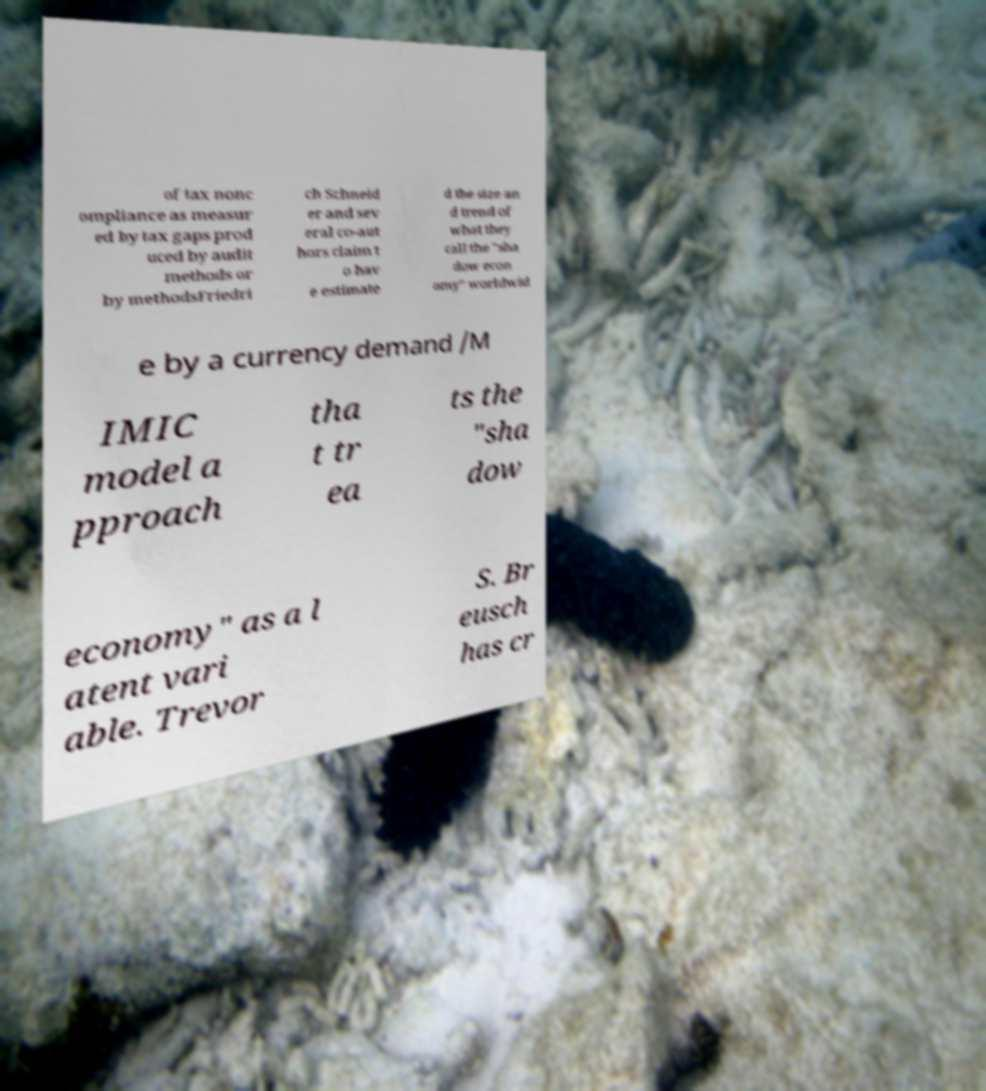Can you accurately transcribe the text from the provided image for me? of tax nonc ompliance as measur ed by tax gaps prod uced by audit methods or by methodsFriedri ch Schneid er and sev eral co-aut hors claim t o hav e estimate d the size an d trend of what they call the "sha dow econ omy" worldwid e by a currency demand /M IMIC model a pproach tha t tr ea ts the "sha dow economy" as a l atent vari able. Trevor S. Br eusch has cr 